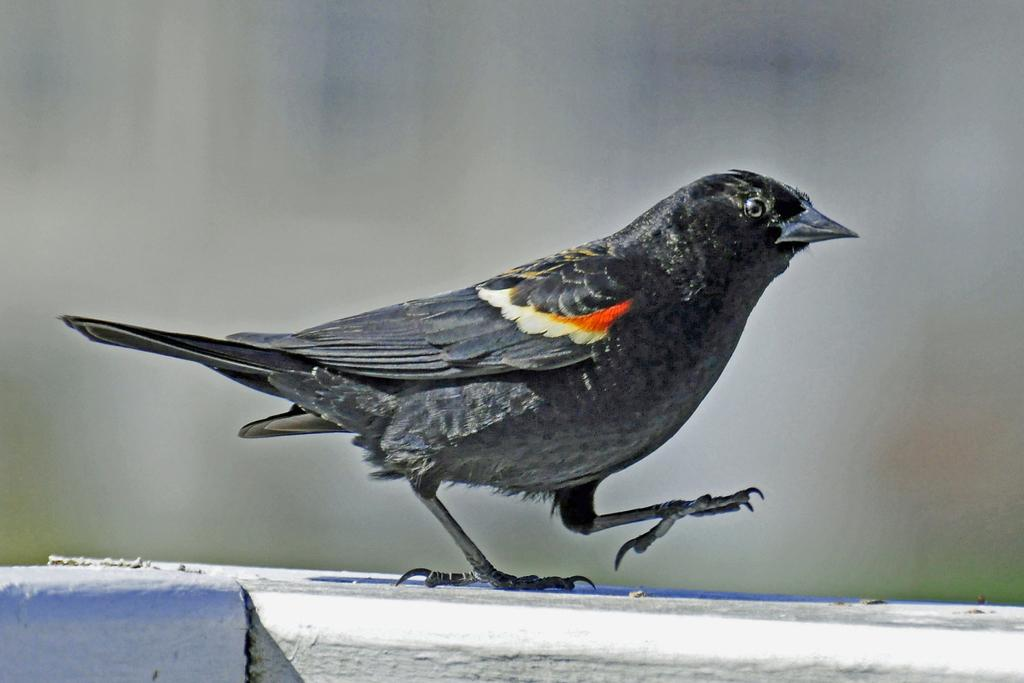What type of animal is in the image? There is a bird in the image. What is the bird standing on? The bird is on a white surface. Can you describe the background of the image? The background of the image is blurry. How many holes can be seen in the bird's play area in the image? There are no holes visible in the image, and the bird is not shown playing. 